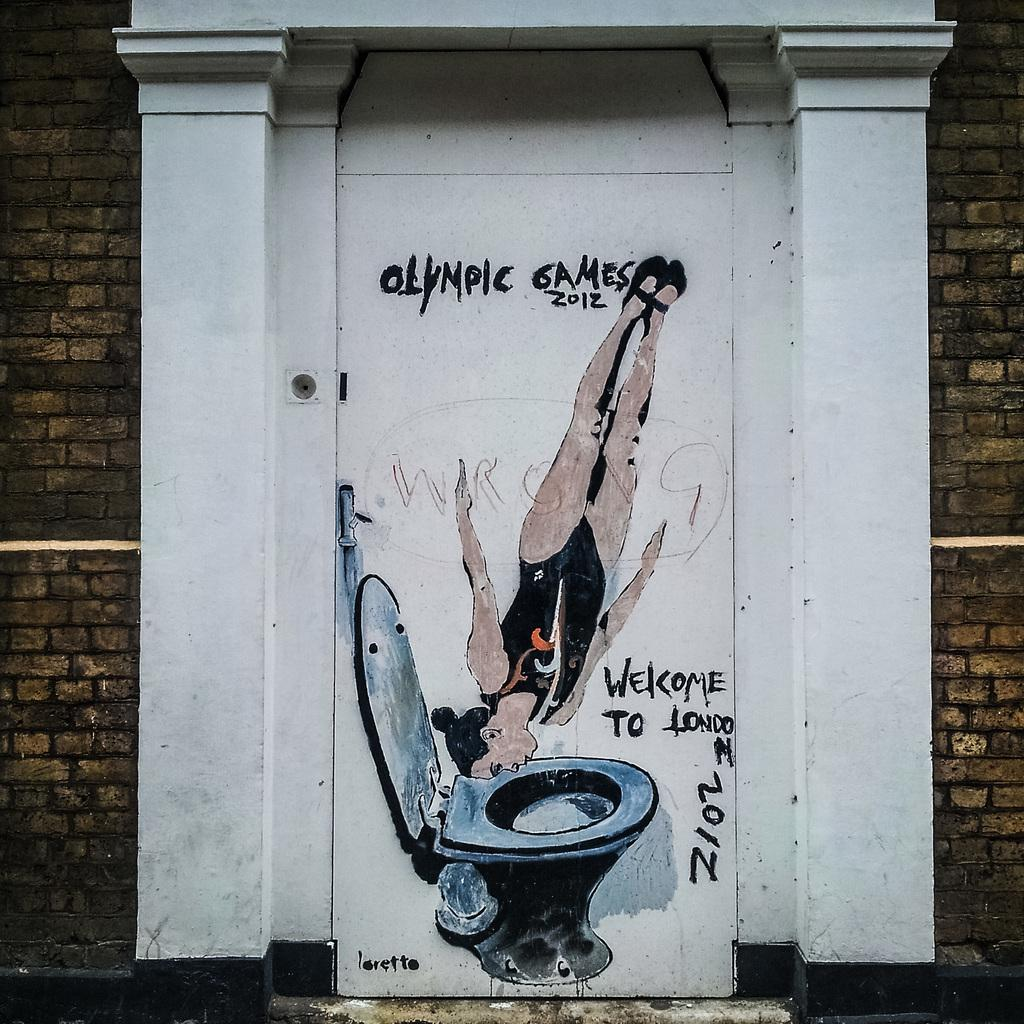Provide a one-sentence caption for the provided image. A woman diving into a toilet along with Olympic Games 2012 are painted on an outside door. 